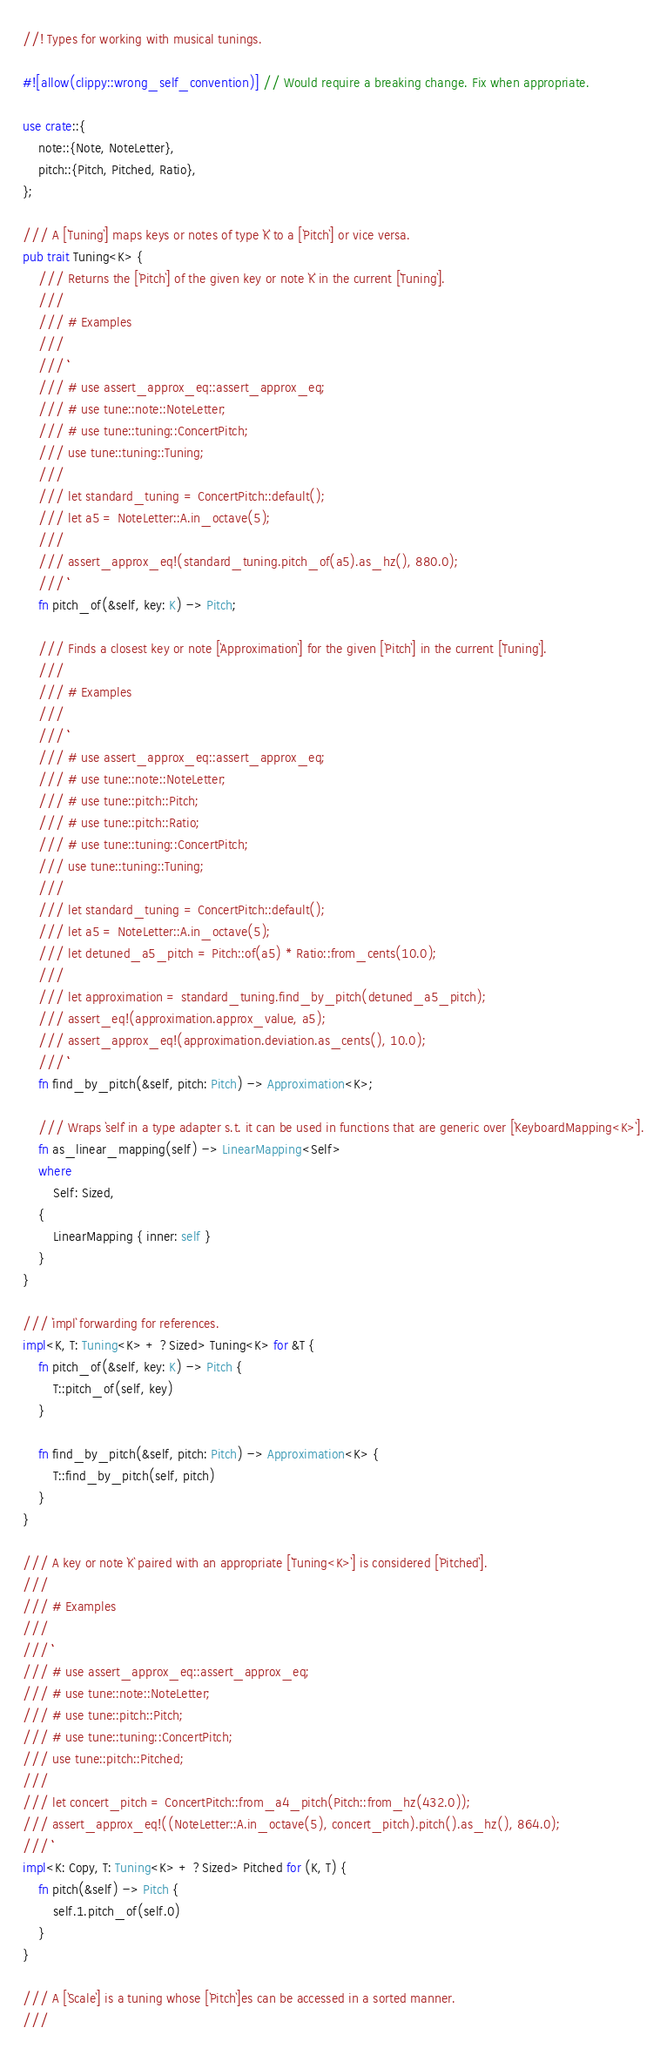<code> <loc_0><loc_0><loc_500><loc_500><_Rust_>//! Types for working with musical tunings.

#![allow(clippy::wrong_self_convention)] // Would require a breaking change. Fix when appropriate.

use crate::{
    note::{Note, NoteLetter},
    pitch::{Pitch, Pitched, Ratio},
};

/// A [`Tuning`] maps keys or notes of type `K` to a [`Pitch`] or vice versa.
pub trait Tuning<K> {
    /// Returns the [`Pitch`] of the given key or note `K` in the current [`Tuning`].
    ///
    /// # Examples
    ///
    /// ```
    /// # use assert_approx_eq::assert_approx_eq;
    /// # use tune::note::NoteLetter;
    /// # use tune::tuning::ConcertPitch;
    /// use tune::tuning::Tuning;
    ///
    /// let standard_tuning = ConcertPitch::default();
    /// let a5 = NoteLetter::A.in_octave(5);
    ///
    /// assert_approx_eq!(standard_tuning.pitch_of(a5).as_hz(), 880.0);
    /// ```
    fn pitch_of(&self, key: K) -> Pitch;

    /// Finds a closest key or note [`Approximation`] for the given [`Pitch`] in the current [`Tuning`].
    ///
    /// # Examples
    ///
    /// ```
    /// # use assert_approx_eq::assert_approx_eq;
    /// # use tune::note::NoteLetter;
    /// # use tune::pitch::Pitch;
    /// # use tune::pitch::Ratio;
    /// # use tune::tuning::ConcertPitch;
    /// use tune::tuning::Tuning;
    ///
    /// let standard_tuning = ConcertPitch::default();
    /// let a5 = NoteLetter::A.in_octave(5);
    /// let detuned_a5_pitch = Pitch::of(a5) * Ratio::from_cents(10.0);
    ///
    /// let approximation = standard_tuning.find_by_pitch(detuned_a5_pitch);
    /// assert_eq!(approximation.approx_value, a5);
    /// assert_approx_eq!(approximation.deviation.as_cents(), 10.0);
    /// ```
    fn find_by_pitch(&self, pitch: Pitch) -> Approximation<K>;

    /// Wraps `self` in a type adapter s.t. it can be used in functions that are generic over [`KeyboardMapping<K>`].
    fn as_linear_mapping(self) -> LinearMapping<Self>
    where
        Self: Sized,
    {
        LinearMapping { inner: self }
    }
}

/// `impl` forwarding for references.
impl<K, T: Tuning<K> + ?Sized> Tuning<K> for &T {
    fn pitch_of(&self, key: K) -> Pitch {
        T::pitch_of(self, key)
    }

    fn find_by_pitch(&self, pitch: Pitch) -> Approximation<K> {
        T::find_by_pitch(self, pitch)
    }
}

/// A key or note `K` paired with an appropriate [`Tuning<K>`] is considered [`Pitched`].
///
/// # Examples
///
/// ```
/// # use assert_approx_eq::assert_approx_eq;
/// # use tune::note::NoteLetter;
/// # use tune::pitch::Pitch;
/// # use tune::tuning::ConcertPitch;
/// use tune::pitch::Pitched;
///
/// let concert_pitch = ConcertPitch::from_a4_pitch(Pitch::from_hz(432.0));
/// assert_approx_eq!((NoteLetter::A.in_octave(5), concert_pitch).pitch().as_hz(), 864.0);
/// ```
impl<K: Copy, T: Tuning<K> + ?Sized> Pitched for (K, T) {
    fn pitch(&self) -> Pitch {
        self.1.pitch_of(self.0)
    }
}

/// A [`Scale`] is a tuning whose [`Pitch`]es can be accessed in a sorted manner.
///</code> 